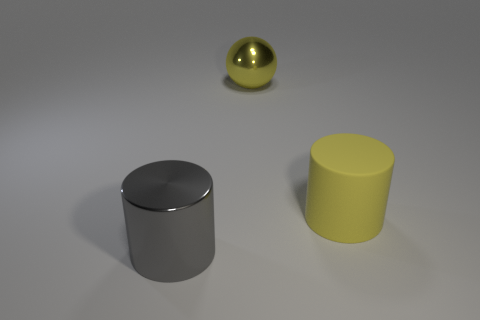There is another object that is the same shape as the big yellow matte thing; what material is it?
Your answer should be compact. Metal. Are there any other things that have the same material as the big ball?
Your answer should be compact. Yes. There is a big yellow rubber thing; are there any rubber cylinders in front of it?
Offer a very short reply. No. How many green matte blocks are there?
Your answer should be very brief. 0. There is a big shiny thing behind the big shiny cylinder; what number of spheres are on the left side of it?
Provide a succinct answer. 0. Is the color of the big ball the same as the big cylinder that is behind the big gray shiny cylinder?
Offer a terse response. Yes. What number of other big yellow shiny objects are the same shape as the large yellow shiny thing?
Make the answer very short. 0. There is a sphere that is to the right of the shiny cylinder; what is it made of?
Ensure brevity in your answer.  Metal. There is a big object that is in front of the rubber thing; does it have the same shape as the rubber thing?
Your answer should be compact. Yes. Is there a shiny cylinder that has the same size as the matte thing?
Make the answer very short. Yes. 